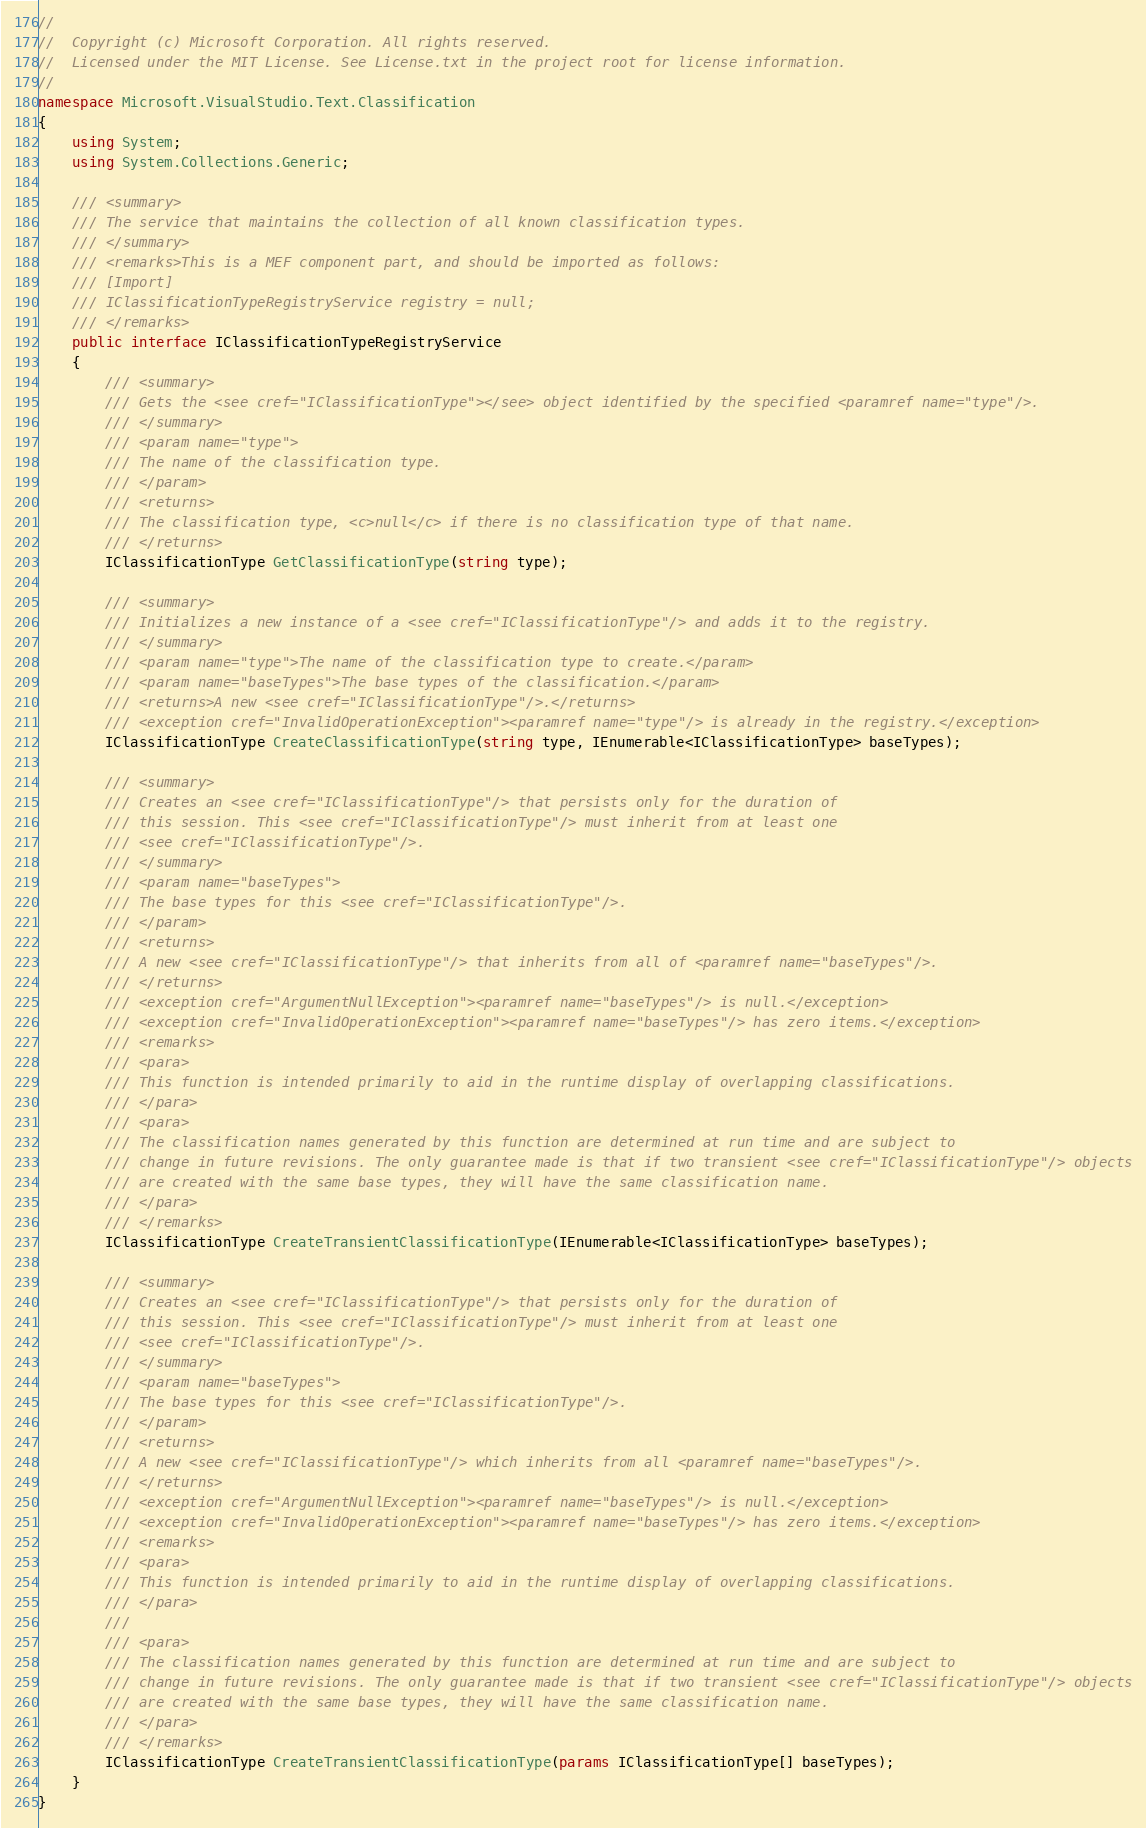<code> <loc_0><loc_0><loc_500><loc_500><_C#_>//
//  Copyright (c) Microsoft Corporation. All rights reserved.
//  Licensed under the MIT License. See License.txt in the project root for license information.
//
namespace Microsoft.VisualStudio.Text.Classification
{
    using System;
    using System.Collections.Generic;

    /// <summary>
    /// The service that maintains the collection of all known classification types.
    /// </summary>
    /// <remarks>This is a MEF component part, and should be imported as follows:
    /// [Import]
    /// IClassificationTypeRegistryService registry = null;
    /// </remarks>
    public interface IClassificationTypeRegistryService
    {
        /// <summary>
        /// Gets the <see cref="IClassificationType"></see> object identified by the specified <paramref name="type"/>.
        /// </summary>
        /// <param name="type">
        /// The name of the classification type.
        /// </param>
        /// <returns>
        /// The classification type, <c>null</c> if there is no classification type of that name.
        /// </returns>
        IClassificationType GetClassificationType(string type);

        /// <summary>
        /// Initializes a new instance of a <see cref="IClassificationType"/> and adds it to the registry.
        /// </summary>
        /// <param name="type">The name of the classification type to create.</param>
        /// <param name="baseTypes">The base types of the classification.</param>
        /// <returns>A new <see cref="IClassificationType"/>.</returns>
        /// <exception cref="InvalidOperationException"><paramref name="type"/> is already in the registry.</exception>
        IClassificationType CreateClassificationType(string type, IEnumerable<IClassificationType> baseTypes);

        /// <summary>
        /// Creates an <see cref="IClassificationType"/> that persists only for the duration of
        /// this session. This <see cref="IClassificationType"/> must inherit from at least one
        /// <see cref="IClassificationType"/>.
        /// </summary>
        /// <param name="baseTypes">
        /// The base types for this <see cref="IClassificationType"/>.
        /// </param>
        /// <returns>
        /// A new <see cref="IClassificationType"/> that inherits from all of <paramref name="baseTypes"/>.
        /// </returns>
        /// <exception cref="ArgumentNullException"><paramref name="baseTypes"/> is null.</exception>
        /// <exception cref="InvalidOperationException"><paramref name="baseTypes"/> has zero items.</exception>
        /// <remarks>
        /// <para>
        /// This function is intended primarily to aid in the runtime display of overlapping classifications.
        /// </para>
        /// <para>
        /// The classification names generated by this function are determined at run time and are subject to
        /// change in future revisions. The only guarantee made is that if two transient <see cref="IClassificationType"/> objects
        /// are created with the same base types, they will have the same classification name.
        /// </para>
        /// </remarks>
        IClassificationType CreateTransientClassificationType(IEnumerable<IClassificationType> baseTypes);

        /// <summary>
        /// Creates an <see cref="IClassificationType"/> that persists only for the duration of
        /// this session. This <see cref="IClassificationType"/> must inherit from at least one
        /// <see cref="IClassificationType"/>.
        /// </summary>
        /// <param name="baseTypes">
        /// The base types for this <see cref="IClassificationType"/>.
        /// </param>
        /// <returns>
        /// A new <see cref="IClassificationType"/> which inherits from all <paramref name="baseTypes"/>.
        /// </returns>
        /// <exception cref="ArgumentNullException"><paramref name="baseTypes"/> is null.</exception>
        /// <exception cref="InvalidOperationException"><paramref name="baseTypes"/> has zero items.</exception>
        /// <remarks>
        /// <para>
        /// This function is intended primarily to aid in the runtime display of overlapping classifications.
        /// </para>
        /// 
        /// <para>
        /// The classification names generated by this function are determined at run time and are subject to
        /// change in future revisions. The only guarantee made is that if two transient <see cref="IClassificationType"/> objects
        /// are created with the same base types, they will have the same classification name.
        /// </para>
        /// </remarks>
        IClassificationType CreateTransientClassificationType(params IClassificationType[] baseTypes);
    }
}
</code> 